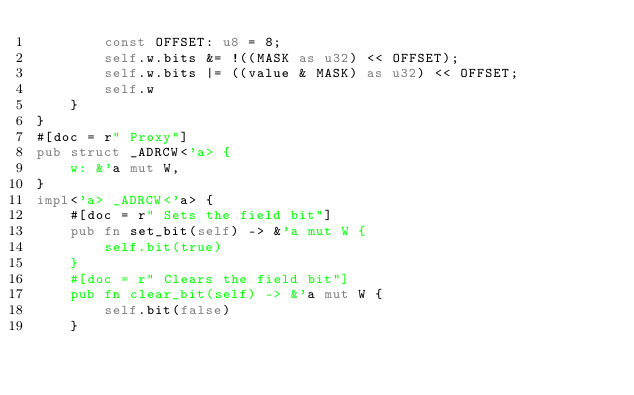<code> <loc_0><loc_0><loc_500><loc_500><_Rust_>        const OFFSET: u8 = 8;
        self.w.bits &= !((MASK as u32) << OFFSET);
        self.w.bits |= ((value & MASK) as u32) << OFFSET;
        self.w
    }
}
#[doc = r" Proxy"]
pub struct _ADRCW<'a> {
    w: &'a mut W,
}
impl<'a> _ADRCW<'a> {
    #[doc = r" Sets the field bit"]
    pub fn set_bit(self) -> &'a mut W {
        self.bit(true)
    }
    #[doc = r" Clears the field bit"]
    pub fn clear_bit(self) -> &'a mut W {
        self.bit(false)
    }</code> 